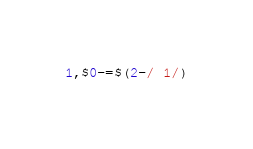Convert code to text. <code><loc_0><loc_0><loc_500><loc_500><_Awk_>1,$0-=$(2-/ 1/)</code> 